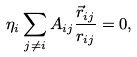<formula> <loc_0><loc_0><loc_500><loc_500>\eta _ { i } \sum _ { j \ne i } A _ { i j } \frac { \vec { r } _ { i j } } { r _ { i j } } = 0 ,</formula> 